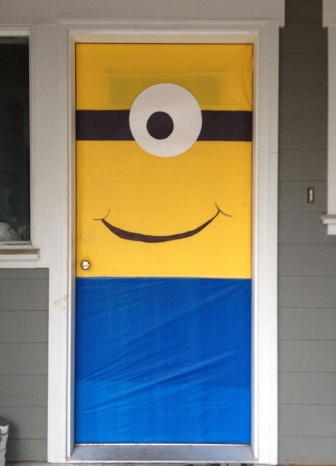If you were to make up a story based on the door decoration in this image, what would it be? Once upon a time in a quaint little neighborhood, there was a house with a magical door adorned with a minion poster. Every night, when the clock struck midnight, the minion on the door would come to life! It would step off the door, stretch, and embark on secret adventures. The minion's mission was to bring joy and laughter to the world. One night, it decided to host a surprise party for the neighborhood animals. With the help of twinkling fireflies and the wise old owl, the minion crafted colorful decorations and cooked delicious treats. When the sun began to rise, the minion returned to its place on the door, leaving the neighborhood animals with cherished memories and a promise of more magical nights to come. 